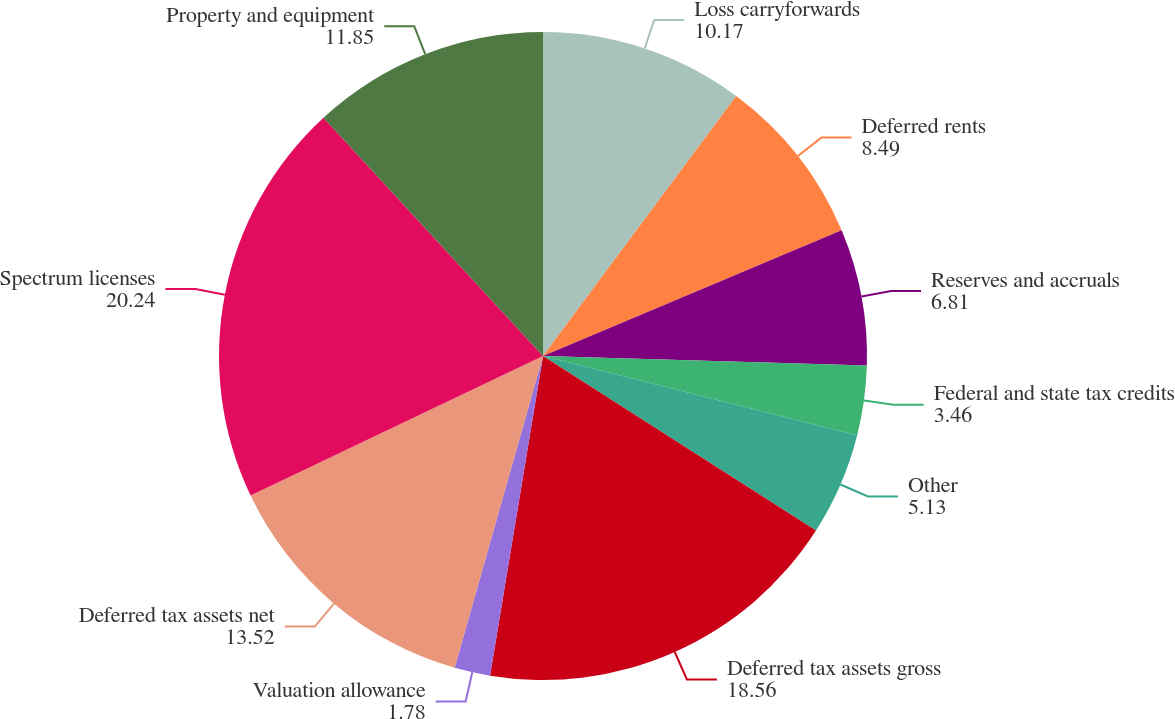Convert chart to OTSL. <chart><loc_0><loc_0><loc_500><loc_500><pie_chart><fcel>Loss carryforwards<fcel>Deferred rents<fcel>Reserves and accruals<fcel>Federal and state tax credits<fcel>Other<fcel>Deferred tax assets gross<fcel>Valuation allowance<fcel>Deferred tax assets net<fcel>Spectrum licenses<fcel>Property and equipment<nl><fcel>10.17%<fcel>8.49%<fcel>6.81%<fcel>3.46%<fcel>5.13%<fcel>18.56%<fcel>1.78%<fcel>13.52%<fcel>20.24%<fcel>11.85%<nl></chart> 